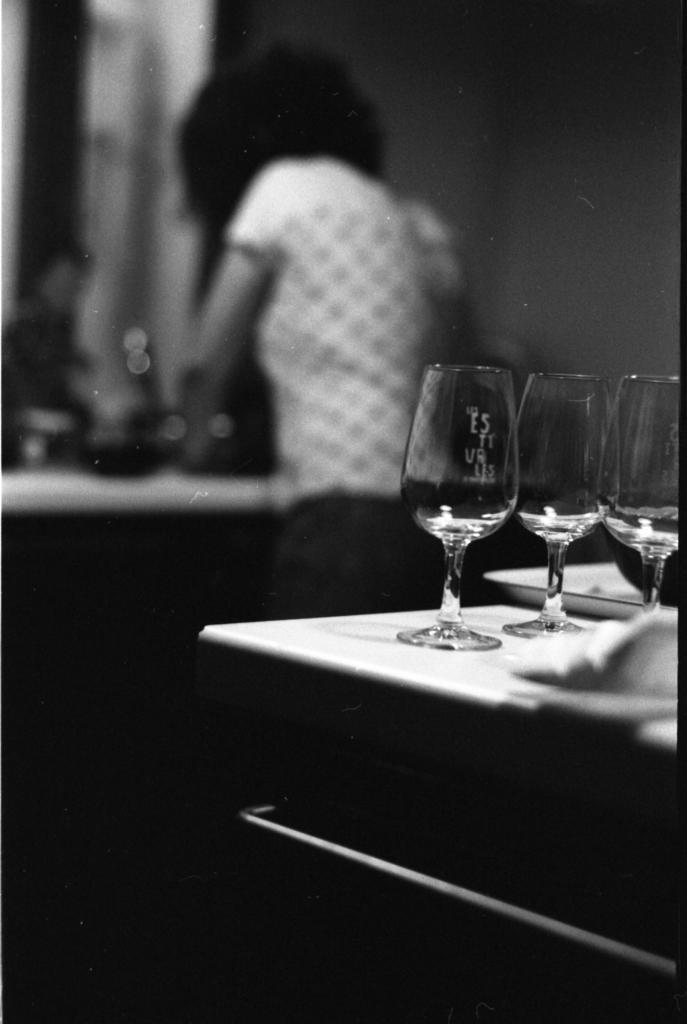Could you give a brief overview of what you see in this image? In the bottom right corner of the image there is a table, on the table there are some glasses and plates. Behind the table a person is standing. Behind her there is wall. 